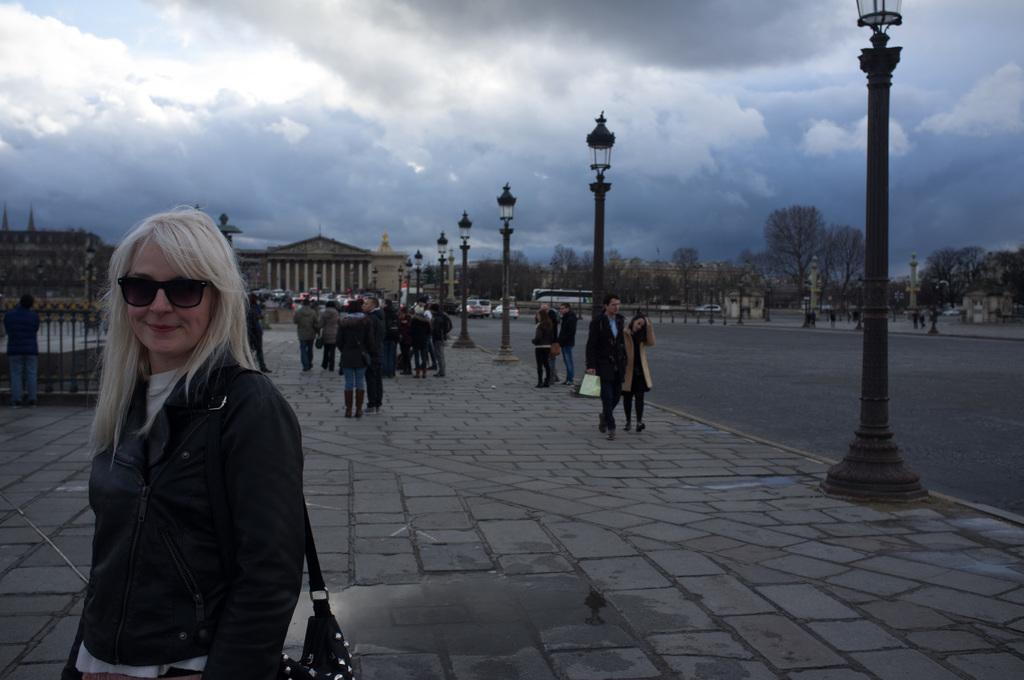How would you summarize this image in a sentence or two? This picture describes about group of people, few are standing and few are walking, on the left side of the image we can see a woman, she is smiling and she wore spectacles, in the background we can see few poles, lights, trees, vehicles and buildings. 